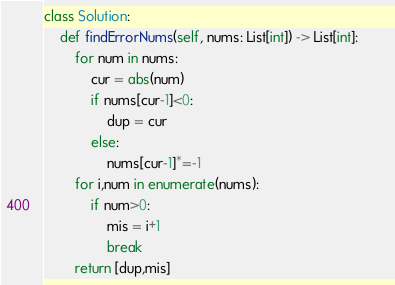<code> <loc_0><loc_0><loc_500><loc_500><_Python_>class Solution:
    def findErrorNums(self, nums: List[int]) -> List[int]:        
        for num in nums:
            cur = abs(num)
            if nums[cur-1]<0:
                dup = cur                           
            else:
                nums[cur-1]*=-1
        for i,num in enumerate(nums):
            if num>0:
                mis = i+1
                break
        return [dup,mis]
</code> 